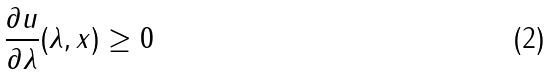Convert formula to latex. <formula><loc_0><loc_0><loc_500><loc_500>\frac { \partial u } { \partial \lambda } ( \lambda , x ) \geq 0</formula> 